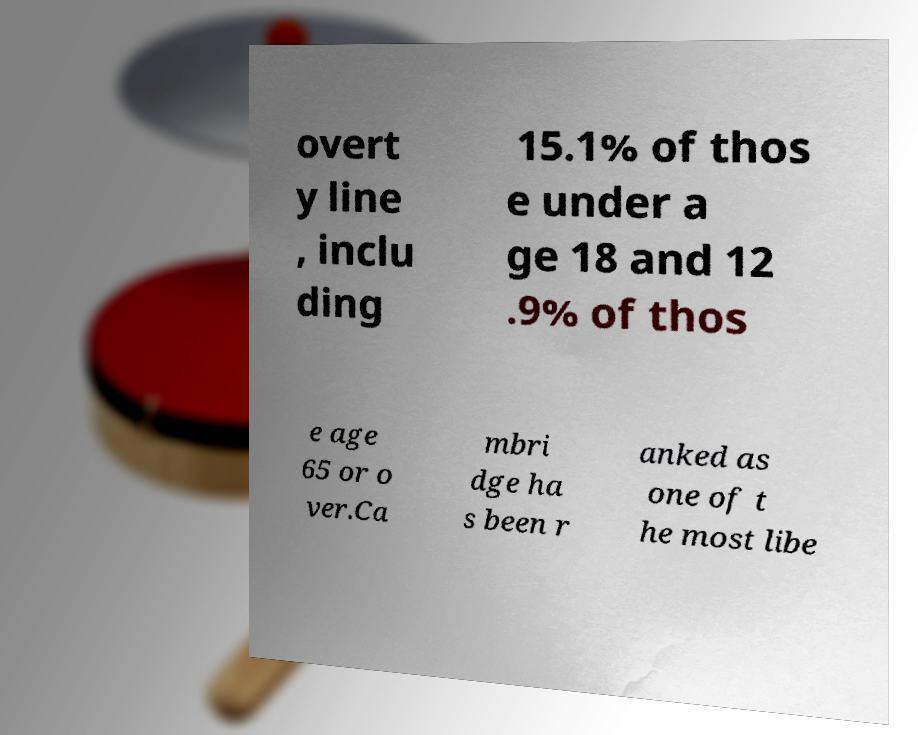There's text embedded in this image that I need extracted. Can you transcribe it verbatim? overt y line , inclu ding 15.1% of thos e under a ge 18 and 12 .9% of thos e age 65 or o ver.Ca mbri dge ha s been r anked as one of t he most libe 